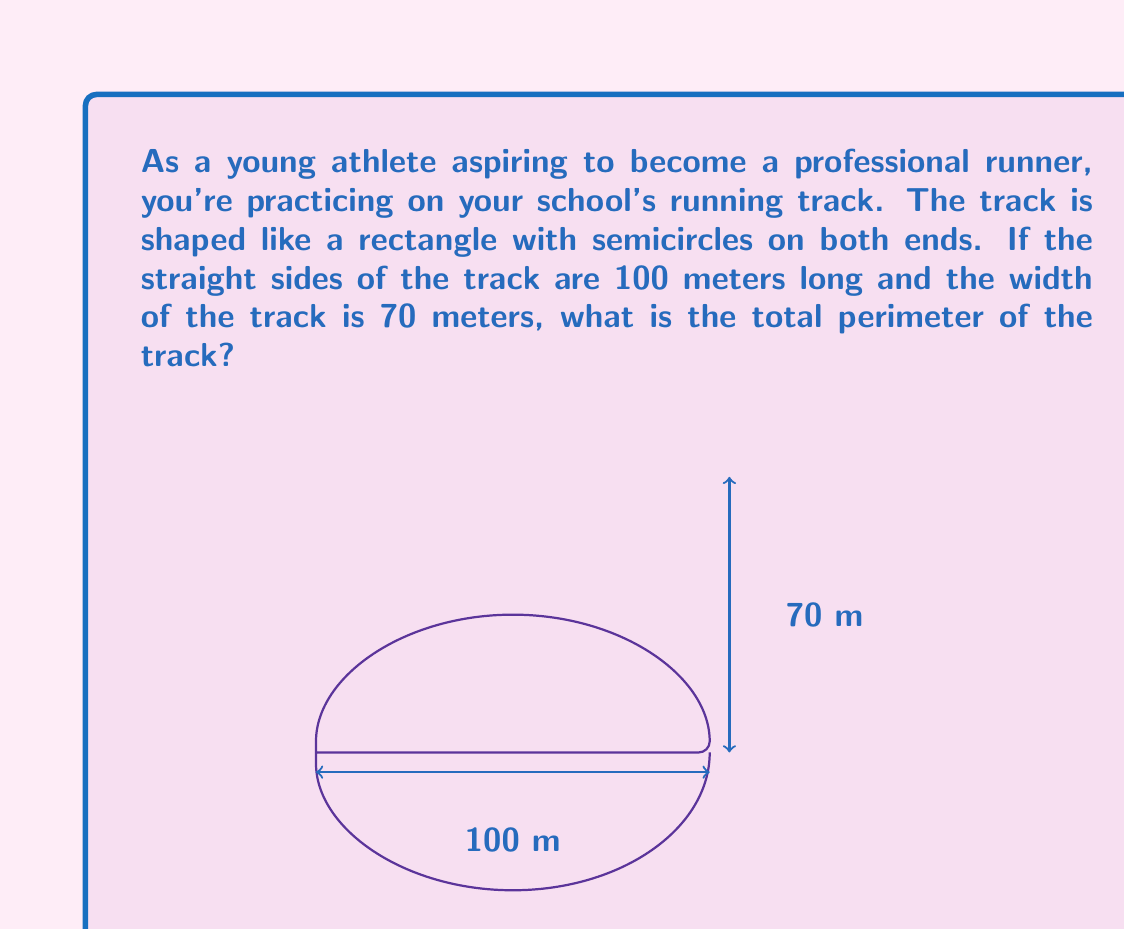Can you solve this math problem? Let's break this down step-by-step:

1) The track is made up of two straight sides and two semicircular ends.

2) We're given that the straight sides are 100 meters long each.

3) The width of the track, 70 meters, is the diameter of each semicircle.

4) To find the perimeter, we need to add:
   - The length of the two straight sides
   - The circumference of a full circle (which is equal to the two semicircles combined)

5) The length of the straight sides is easy: $2 \times 100 = 200$ meters

6) For the semicircles, we need to calculate the circumference of a circle with diameter 70 meters:
   - The formula for circumference is $C = \pi d$, where $d$ is the diameter
   - $C = \pi \times 70$

7) Now we can add these together:
   $\text{Perimeter} = 200 + \pi \times 70$

8) Let's calculate this:
   $\text{Perimeter} = 200 + \pi \times 70 \approx 200 + 219.91 \approx 419.91$ meters

Therefore, the perimeter of the track is approximately 419.91 meters.
Answer: The perimeter of the running track is $200 + 70\pi \approx 419.91$ meters. 